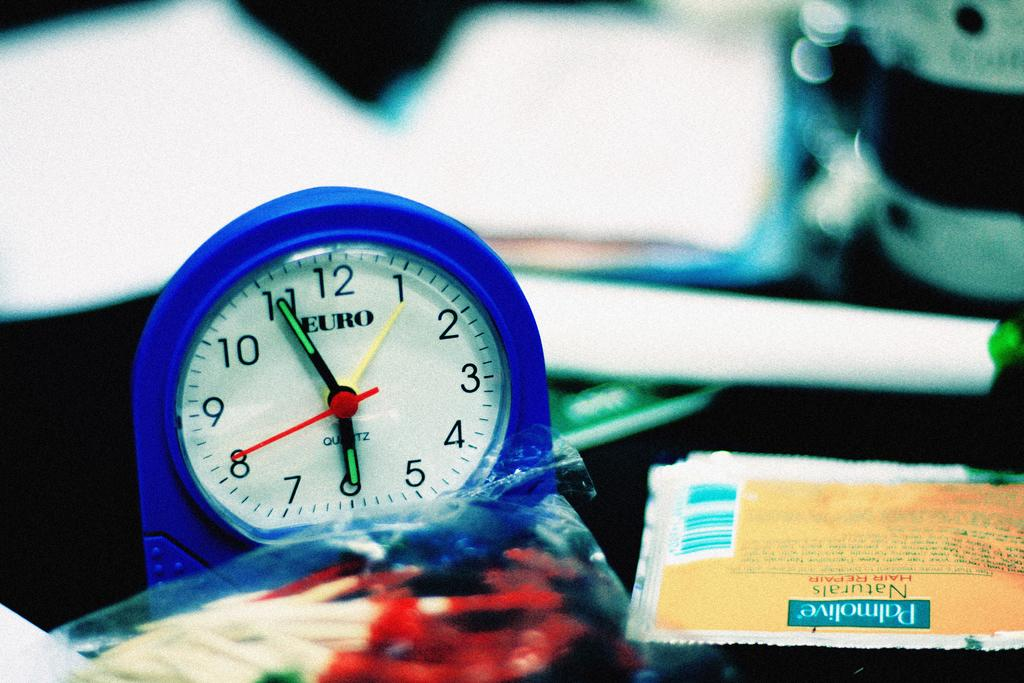<image>
Describe the image concisely. A small blue Euro clock has a red second hand. 